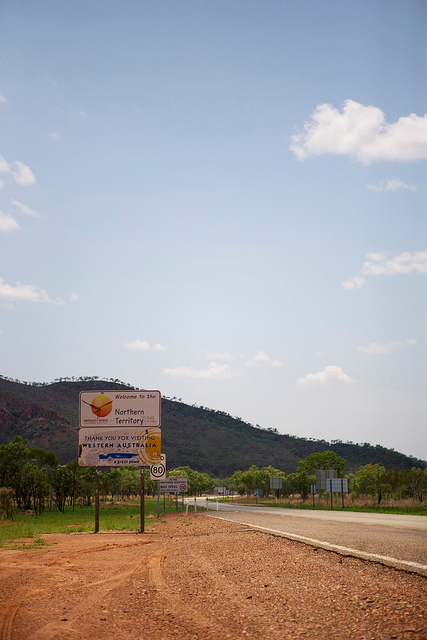Read and extract the text from this image. Territory WESTERN THAHI 80 AUSTRALIA 